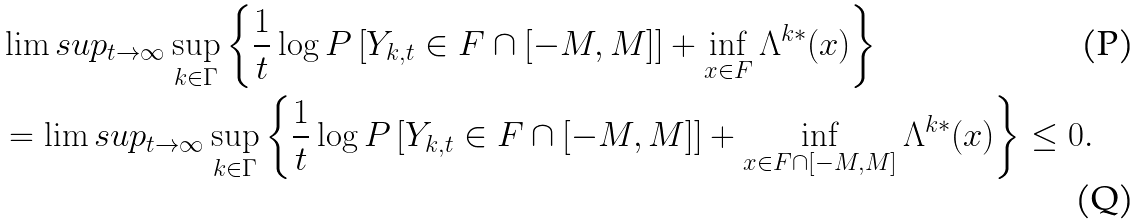Convert formula to latex. <formula><loc_0><loc_0><loc_500><loc_500>& \lim s u p _ { t \rightarrow \infty } \sup _ { k \in \Gamma } \left \{ \frac { 1 } { t } \log P \left [ Y _ { k , t } \in F \cap [ - M , M ] \right ] + \inf _ { x \in F } \Lambda ^ { k * } ( x ) \right \} \\ & = \lim s u p _ { t \rightarrow \infty } \sup _ { k \in \Gamma } \left \{ \frac { 1 } { t } \log P \left [ Y _ { k , t } \in F \cap [ - M , M ] \right ] + \inf _ { x \in F \cap [ - M , M ] } \Lambda ^ { k * } ( x ) \right \} \leq 0 .</formula> 